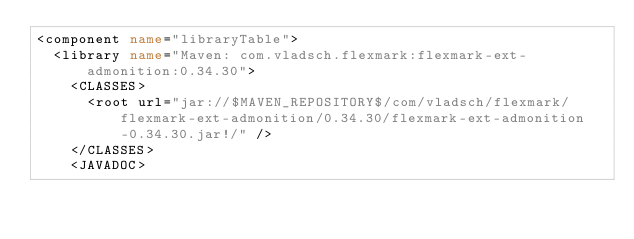Convert code to text. <code><loc_0><loc_0><loc_500><loc_500><_XML_><component name="libraryTable">
  <library name="Maven: com.vladsch.flexmark:flexmark-ext-admonition:0.34.30">
    <CLASSES>
      <root url="jar://$MAVEN_REPOSITORY$/com/vladsch/flexmark/flexmark-ext-admonition/0.34.30/flexmark-ext-admonition-0.34.30.jar!/" />
    </CLASSES>
    <JAVADOC></code> 